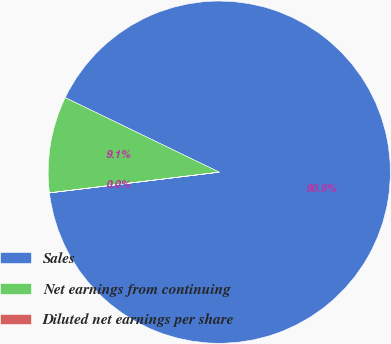Convert chart to OTSL. <chart><loc_0><loc_0><loc_500><loc_500><pie_chart><fcel>Sales<fcel>Net earnings from continuing<fcel>Diluted net earnings per share<nl><fcel>90.89%<fcel>9.1%<fcel>0.01%<nl></chart> 